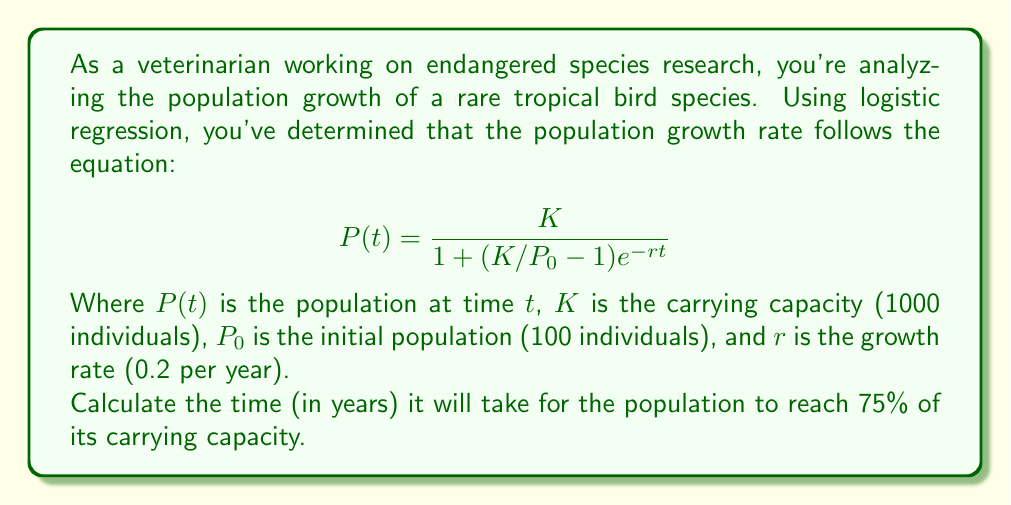Give your solution to this math problem. To solve this problem, we need to follow these steps:

1) First, let's identify what we're looking for. We want to find $t$ when $P(t) = 0.75K = 750$ individuals.

2) We can substitute the known values into the logistic growth equation:

   $$750 = \frac{1000}{1 + (1000/100 - 1)e^{-0.2t}}$$

3) Now, let's solve this equation for $t$:

   $$750(1 + 9e^{-0.2t}) = 1000$$
   $$750 + 6750e^{-0.2t} = 1000$$
   $$6750e^{-0.2t} = 250$$
   $$e^{-0.2t} = \frac{250}{6750} = \frac{1}{27}$$

4) Taking the natural log of both sides:

   $$-0.2t = \ln(\frac{1}{27})$$
   $$t = -\frac{\ln(\frac{1}{27})}{0.2}$$

5) We can simplify $\ln(\frac{1}{27})$ to $-\ln(27)$:

   $$t = \frac{\ln(27)}{0.2}$$

6) Now we can calculate:

   $$t = \frac{3.2958}{0.2} = 16.479$$

Therefore, it will take approximately 16.48 years for the population to reach 75% of its carrying capacity.
Answer: 16.48 years 